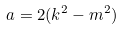<formula> <loc_0><loc_0><loc_500><loc_500>a = 2 ( k ^ { 2 } - m ^ { 2 } )</formula> 